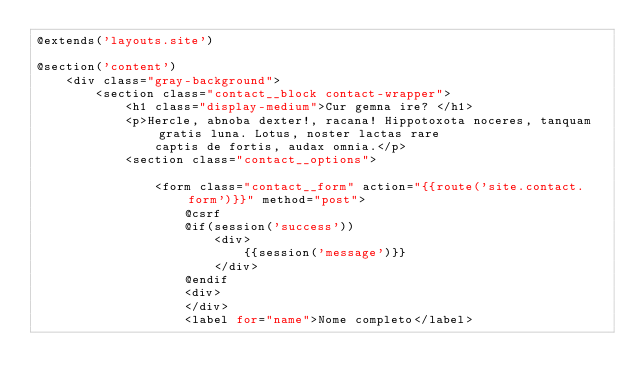<code> <loc_0><loc_0><loc_500><loc_500><_PHP_>@extends('layouts.site')

@section('content')
    <div class="gray-background">
        <section class="contact__block contact-wrapper">
            <h1 class="display-medium">Cur gemna ire? </h1>
            <p>Hercle, abnoba dexter!, racana! Hippotoxota noceres, tanquam gratis luna. Lotus, noster lactas rare
                captis de fortis, audax omnia.</p>
            <section class="contact__options">

                <form class="contact__form" action="{{route('site.contact.form')}}" method="post">
                    @csrf
                    @if(session('success'))
                        <div>
                            {{session('message')}}
                        </div>
                    @endif
                    <div>
                    </div>
                    <label for="name">Nome completo</label></code> 